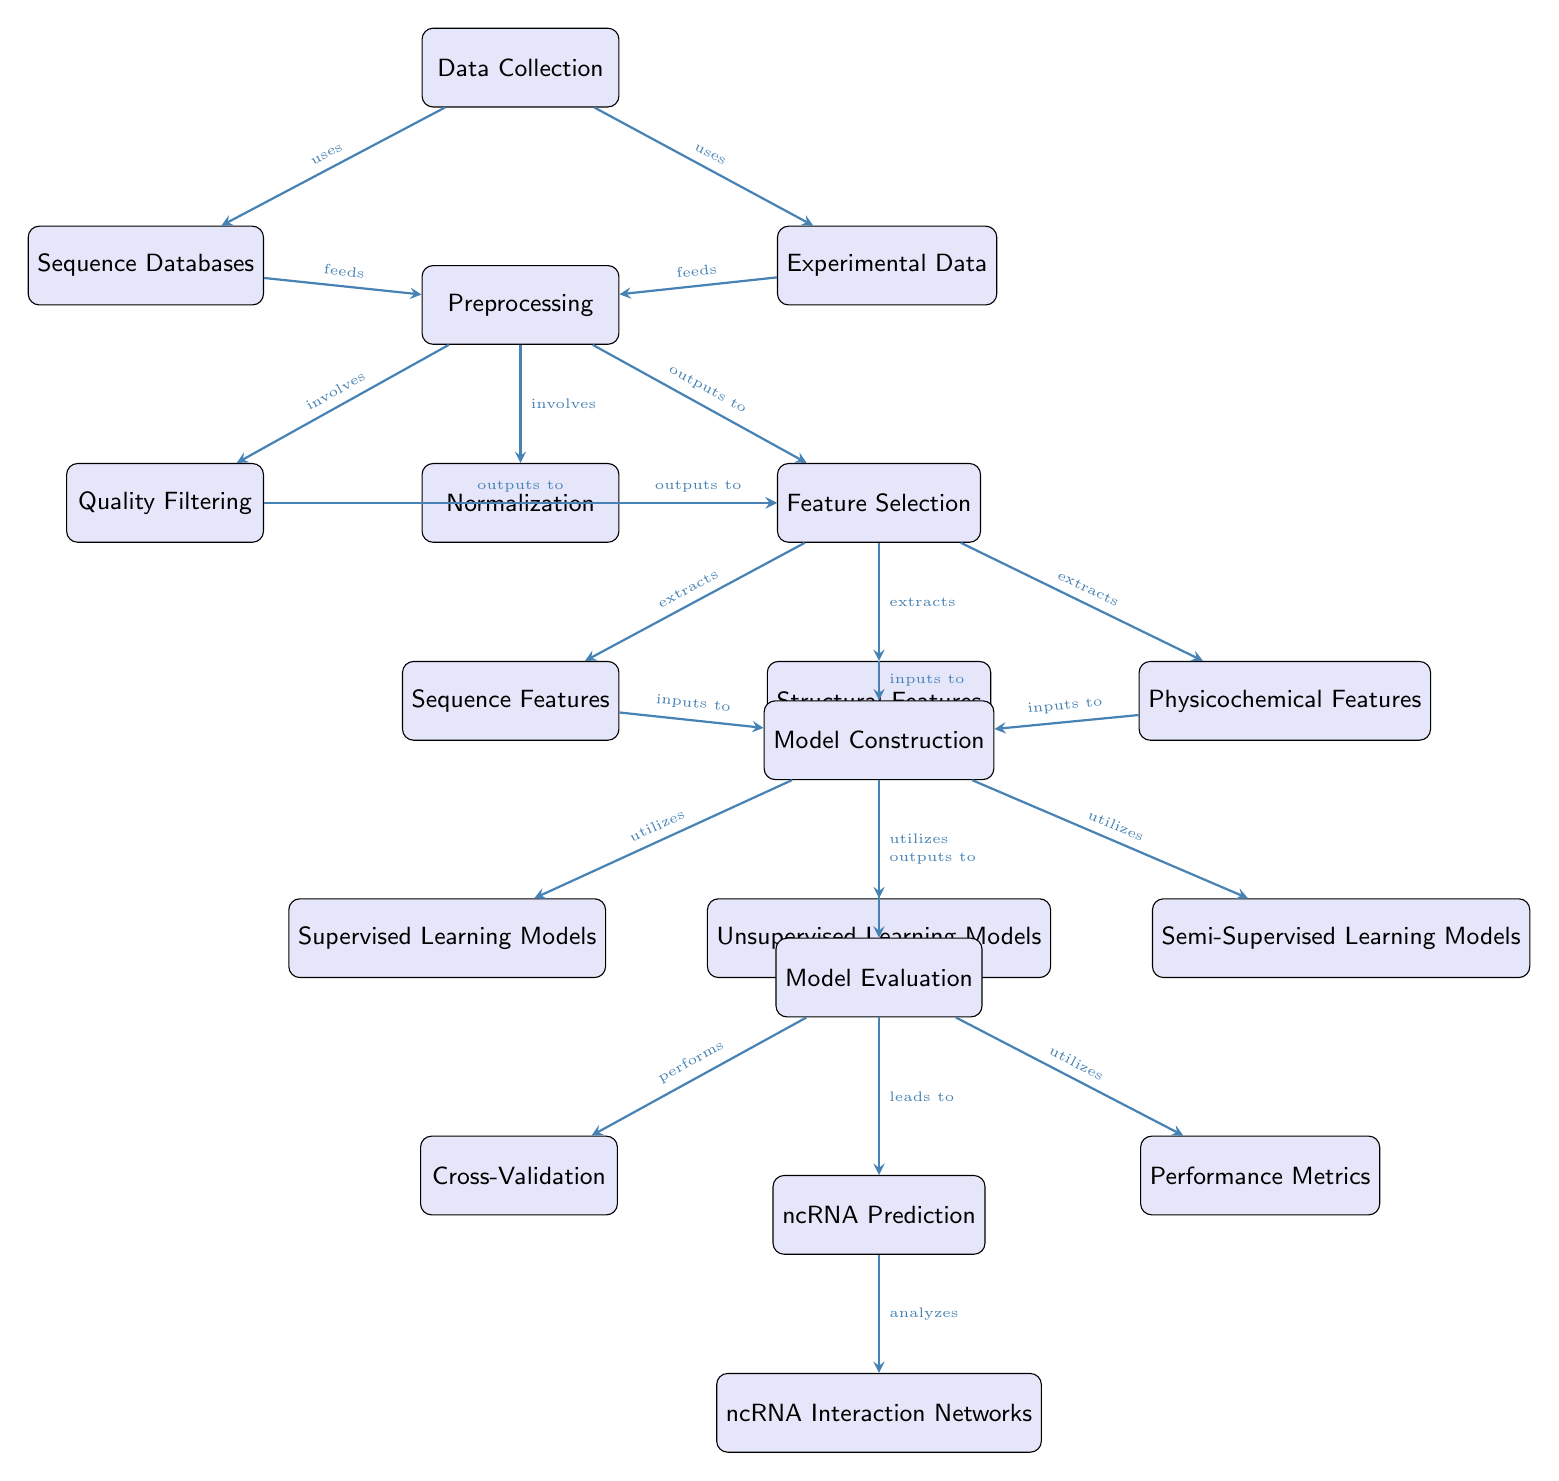What are the two sources used for data collection? The diagram shows two primary sources for data collection: Sequence Databases and Experimental Data. These are situated below the Data Collection node.
Answer: Sequence Databases, Experimental Data How many types of features are extracted after feature selection? The feature selection node leads to three different types of features being extracted. These are Sequence Features, Structural Features, and Physicochemical Features.
Answer: Three What is the first step after preprocessing? According to the diagram, the step following preprocessing is feature selection. This step is directly connected to the preprocessing node.
Answer: Feature Selection Which machine learning models are utilized in model construction? The diagram identifies three types of machine learning models under model construction: Supervised Learning Models, Unsupervised Learning Models, and Semi-Supervised Learning Models.
Answer: Supervised, Unsupervised, Semi-Supervised What process leads to ncRNA prediction? The model evaluation node directly feeds into the ncRNA prediction node. Therefore, model evaluation is the process that leads to ncRNA prediction.
Answer: Model Evaluation What are the two components that model evaluation performs? From the model evaluation node, two components are indicated: Cross-Validation and Performance Metrics. This means model evaluation performs both of these tasks.
Answer: Cross-Validation, Performance Metrics Which node is responsible for analyzing ncRNA interaction networks? The interaction networks node is the endpoint of the pipeline which analyzes the output from the ncRNA prediction, making it responsible for this analysis.
Answer: Interaction Networks What follows after the model construction phase? The diagram indicates that after model construction, the next phase is model evaluation. It flows directly from model construction to model evaluation.
Answer: Model Evaluation What is the output of the feature selection process? The feature selection process produces three outputs: Sequence Features, Structural Features, and Physicochemical Features. This is evident from the diagram showing all extracted features from the feature selection node.
Answer: Sequence Features, Structural Features, Physicochemical Features 